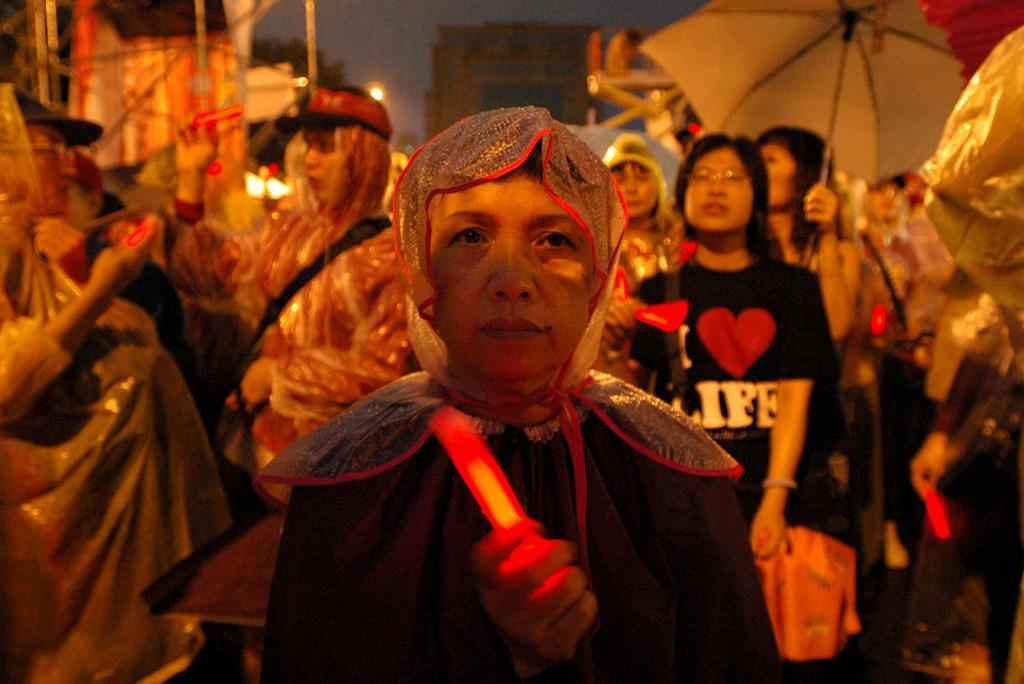Who is the main subject in the image? There is a lady in the image. What is the lady wearing in the image? The lady is wearing a scarf in the image. What is the lady holding in the image? The lady is holding something in the image. Can you describe the background of the image? There are many persons in the background of the image, and one of them is a lady holding an umbrella. What type of wine is the lady drinking in the image? There is no wine present in the image; the lady is holding something else. Who is the lady representing in the image? The image does not indicate that the lady is a representative of any organization or group. 